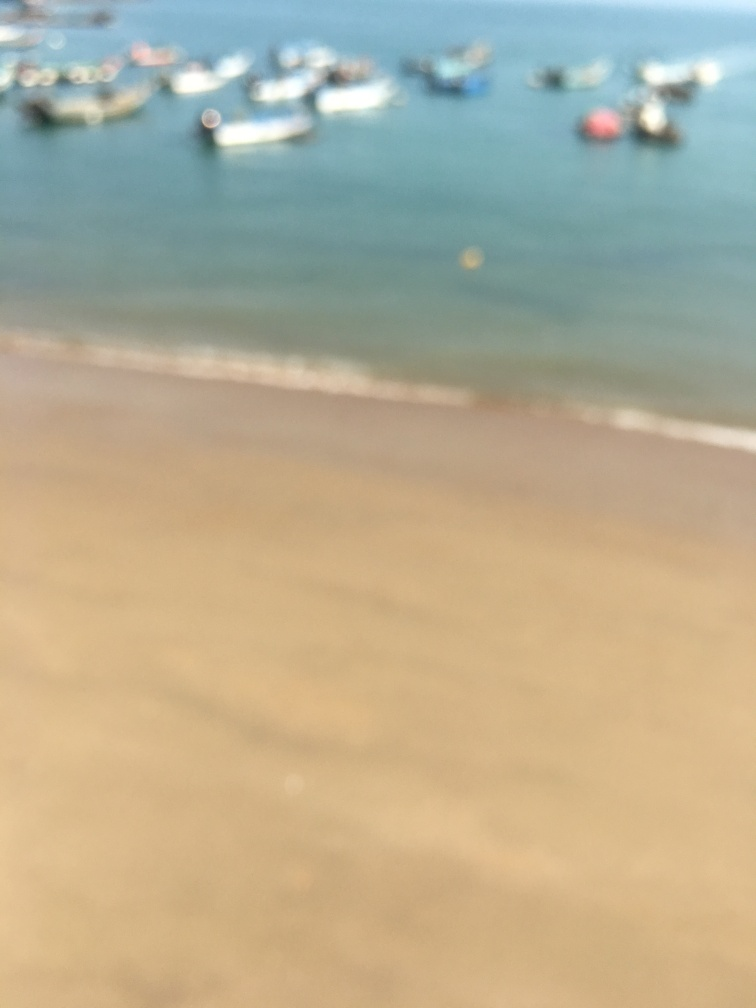What mood or atmosphere does the blurriness of this image convey? The blurriness creates a tranquil, serene mood, almost like a memory or a daydream. It evokes a sense of calmness and may stir feelings of nostalgia as if one is recalling a serene day spent near the water without the sharp details associated with reality. 